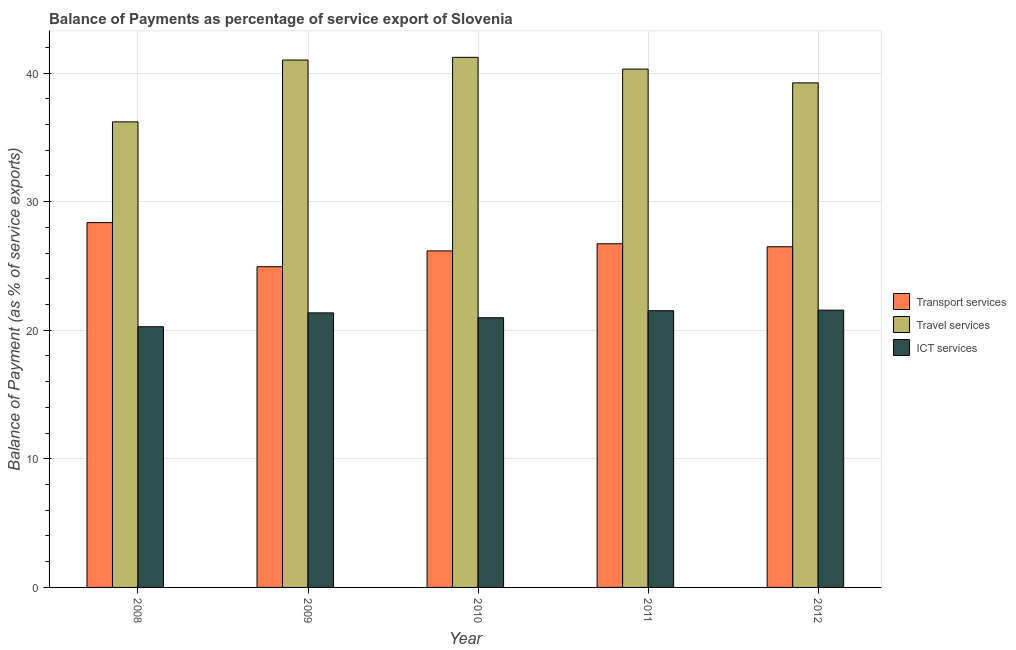How many different coloured bars are there?
Ensure brevity in your answer.  3. How many groups of bars are there?
Your answer should be compact. 5. Are the number of bars on each tick of the X-axis equal?
Provide a short and direct response. Yes. How many bars are there on the 5th tick from the left?
Your answer should be compact. 3. How many bars are there on the 3rd tick from the right?
Provide a succinct answer. 3. What is the label of the 1st group of bars from the left?
Ensure brevity in your answer.  2008. What is the balance of payment of travel services in 2009?
Provide a succinct answer. 41.01. Across all years, what is the maximum balance of payment of transport services?
Offer a terse response. 28.37. Across all years, what is the minimum balance of payment of ict services?
Provide a succinct answer. 20.27. What is the total balance of payment of travel services in the graph?
Provide a short and direct response. 197.99. What is the difference between the balance of payment of ict services in 2009 and that in 2012?
Give a very brief answer. -0.21. What is the difference between the balance of payment of travel services in 2010 and the balance of payment of transport services in 2012?
Provide a short and direct response. 1.99. What is the average balance of payment of ict services per year?
Make the answer very short. 21.14. In the year 2010, what is the difference between the balance of payment of ict services and balance of payment of transport services?
Your answer should be very brief. 0. What is the ratio of the balance of payment of transport services in 2008 to that in 2010?
Your answer should be very brief. 1.08. Is the difference between the balance of payment of travel services in 2009 and 2011 greater than the difference between the balance of payment of ict services in 2009 and 2011?
Make the answer very short. No. What is the difference between the highest and the second highest balance of payment of ict services?
Offer a terse response. 0.04. What is the difference between the highest and the lowest balance of payment of travel services?
Provide a short and direct response. 5.02. In how many years, is the balance of payment of travel services greater than the average balance of payment of travel services taken over all years?
Provide a succinct answer. 3. What does the 3rd bar from the left in 2010 represents?
Ensure brevity in your answer.  ICT services. What does the 2nd bar from the right in 2008 represents?
Provide a succinct answer. Travel services. Is it the case that in every year, the sum of the balance of payment of transport services and balance of payment of travel services is greater than the balance of payment of ict services?
Ensure brevity in your answer.  Yes. How many bars are there?
Keep it short and to the point. 15. Are all the bars in the graph horizontal?
Offer a very short reply. No. How many years are there in the graph?
Make the answer very short. 5. What is the difference between two consecutive major ticks on the Y-axis?
Provide a succinct answer. 10. Are the values on the major ticks of Y-axis written in scientific E-notation?
Offer a very short reply. No. Does the graph contain grids?
Offer a terse response. Yes. How many legend labels are there?
Your response must be concise. 3. What is the title of the graph?
Keep it short and to the point. Balance of Payments as percentage of service export of Slovenia. Does "Infant(male)" appear as one of the legend labels in the graph?
Offer a very short reply. No. What is the label or title of the Y-axis?
Ensure brevity in your answer.  Balance of Payment (as % of service exports). What is the Balance of Payment (as % of service exports) in Transport services in 2008?
Offer a terse response. 28.37. What is the Balance of Payment (as % of service exports) of Travel services in 2008?
Provide a short and direct response. 36.2. What is the Balance of Payment (as % of service exports) in ICT services in 2008?
Keep it short and to the point. 20.27. What is the Balance of Payment (as % of service exports) of Transport services in 2009?
Your response must be concise. 24.94. What is the Balance of Payment (as % of service exports) in Travel services in 2009?
Provide a succinct answer. 41.01. What is the Balance of Payment (as % of service exports) of ICT services in 2009?
Provide a short and direct response. 21.35. What is the Balance of Payment (as % of service exports) of Transport services in 2010?
Your answer should be very brief. 26.17. What is the Balance of Payment (as % of service exports) in Travel services in 2010?
Give a very brief answer. 41.22. What is the Balance of Payment (as % of service exports) of ICT services in 2010?
Provide a short and direct response. 20.97. What is the Balance of Payment (as % of service exports) in Transport services in 2011?
Your answer should be compact. 26.73. What is the Balance of Payment (as % of service exports) in Travel services in 2011?
Your answer should be very brief. 40.31. What is the Balance of Payment (as % of service exports) of ICT services in 2011?
Provide a short and direct response. 21.52. What is the Balance of Payment (as % of service exports) in Transport services in 2012?
Offer a very short reply. 26.49. What is the Balance of Payment (as % of service exports) of Travel services in 2012?
Offer a terse response. 39.24. What is the Balance of Payment (as % of service exports) in ICT services in 2012?
Give a very brief answer. 21.56. Across all years, what is the maximum Balance of Payment (as % of service exports) of Transport services?
Give a very brief answer. 28.37. Across all years, what is the maximum Balance of Payment (as % of service exports) in Travel services?
Keep it short and to the point. 41.22. Across all years, what is the maximum Balance of Payment (as % of service exports) in ICT services?
Offer a very short reply. 21.56. Across all years, what is the minimum Balance of Payment (as % of service exports) of Transport services?
Give a very brief answer. 24.94. Across all years, what is the minimum Balance of Payment (as % of service exports) in Travel services?
Offer a terse response. 36.2. Across all years, what is the minimum Balance of Payment (as % of service exports) of ICT services?
Your response must be concise. 20.27. What is the total Balance of Payment (as % of service exports) in Transport services in the graph?
Provide a succinct answer. 132.7. What is the total Balance of Payment (as % of service exports) of Travel services in the graph?
Offer a terse response. 197.99. What is the total Balance of Payment (as % of service exports) of ICT services in the graph?
Your answer should be very brief. 105.68. What is the difference between the Balance of Payment (as % of service exports) in Transport services in 2008 and that in 2009?
Provide a succinct answer. 3.43. What is the difference between the Balance of Payment (as % of service exports) in Travel services in 2008 and that in 2009?
Your answer should be compact. -4.81. What is the difference between the Balance of Payment (as % of service exports) of ICT services in 2008 and that in 2009?
Ensure brevity in your answer.  -1.08. What is the difference between the Balance of Payment (as % of service exports) of Transport services in 2008 and that in 2010?
Give a very brief answer. 2.2. What is the difference between the Balance of Payment (as % of service exports) in Travel services in 2008 and that in 2010?
Provide a succinct answer. -5.02. What is the difference between the Balance of Payment (as % of service exports) in ICT services in 2008 and that in 2010?
Your answer should be very brief. -0.7. What is the difference between the Balance of Payment (as % of service exports) in Transport services in 2008 and that in 2011?
Provide a short and direct response. 1.65. What is the difference between the Balance of Payment (as % of service exports) in Travel services in 2008 and that in 2011?
Offer a very short reply. -4.1. What is the difference between the Balance of Payment (as % of service exports) in ICT services in 2008 and that in 2011?
Your answer should be compact. -1.25. What is the difference between the Balance of Payment (as % of service exports) in Transport services in 2008 and that in 2012?
Offer a terse response. 1.88. What is the difference between the Balance of Payment (as % of service exports) in Travel services in 2008 and that in 2012?
Provide a succinct answer. -3.03. What is the difference between the Balance of Payment (as % of service exports) in ICT services in 2008 and that in 2012?
Provide a short and direct response. -1.29. What is the difference between the Balance of Payment (as % of service exports) in Transport services in 2009 and that in 2010?
Offer a terse response. -1.23. What is the difference between the Balance of Payment (as % of service exports) of Travel services in 2009 and that in 2010?
Offer a very short reply. -0.21. What is the difference between the Balance of Payment (as % of service exports) in ICT services in 2009 and that in 2010?
Ensure brevity in your answer.  0.38. What is the difference between the Balance of Payment (as % of service exports) of Transport services in 2009 and that in 2011?
Offer a terse response. -1.79. What is the difference between the Balance of Payment (as % of service exports) in Travel services in 2009 and that in 2011?
Keep it short and to the point. 0.7. What is the difference between the Balance of Payment (as % of service exports) of ICT services in 2009 and that in 2011?
Provide a succinct answer. -0.17. What is the difference between the Balance of Payment (as % of service exports) in Transport services in 2009 and that in 2012?
Provide a short and direct response. -1.55. What is the difference between the Balance of Payment (as % of service exports) in Travel services in 2009 and that in 2012?
Offer a very short reply. 1.77. What is the difference between the Balance of Payment (as % of service exports) in ICT services in 2009 and that in 2012?
Your answer should be compact. -0.21. What is the difference between the Balance of Payment (as % of service exports) of Transport services in 2010 and that in 2011?
Ensure brevity in your answer.  -0.55. What is the difference between the Balance of Payment (as % of service exports) in Travel services in 2010 and that in 2011?
Your response must be concise. 0.92. What is the difference between the Balance of Payment (as % of service exports) of ICT services in 2010 and that in 2011?
Keep it short and to the point. -0.55. What is the difference between the Balance of Payment (as % of service exports) of Transport services in 2010 and that in 2012?
Your answer should be very brief. -0.32. What is the difference between the Balance of Payment (as % of service exports) in Travel services in 2010 and that in 2012?
Make the answer very short. 1.99. What is the difference between the Balance of Payment (as % of service exports) in ICT services in 2010 and that in 2012?
Offer a terse response. -0.59. What is the difference between the Balance of Payment (as % of service exports) of Transport services in 2011 and that in 2012?
Offer a terse response. 0.23. What is the difference between the Balance of Payment (as % of service exports) of Travel services in 2011 and that in 2012?
Ensure brevity in your answer.  1.07. What is the difference between the Balance of Payment (as % of service exports) in ICT services in 2011 and that in 2012?
Give a very brief answer. -0.04. What is the difference between the Balance of Payment (as % of service exports) in Transport services in 2008 and the Balance of Payment (as % of service exports) in Travel services in 2009?
Your response must be concise. -12.64. What is the difference between the Balance of Payment (as % of service exports) of Transport services in 2008 and the Balance of Payment (as % of service exports) of ICT services in 2009?
Provide a succinct answer. 7.02. What is the difference between the Balance of Payment (as % of service exports) in Travel services in 2008 and the Balance of Payment (as % of service exports) in ICT services in 2009?
Provide a succinct answer. 14.85. What is the difference between the Balance of Payment (as % of service exports) of Transport services in 2008 and the Balance of Payment (as % of service exports) of Travel services in 2010?
Provide a succinct answer. -12.85. What is the difference between the Balance of Payment (as % of service exports) in Transport services in 2008 and the Balance of Payment (as % of service exports) in ICT services in 2010?
Ensure brevity in your answer.  7.4. What is the difference between the Balance of Payment (as % of service exports) of Travel services in 2008 and the Balance of Payment (as % of service exports) of ICT services in 2010?
Provide a short and direct response. 15.23. What is the difference between the Balance of Payment (as % of service exports) of Transport services in 2008 and the Balance of Payment (as % of service exports) of Travel services in 2011?
Offer a terse response. -11.94. What is the difference between the Balance of Payment (as % of service exports) in Transport services in 2008 and the Balance of Payment (as % of service exports) in ICT services in 2011?
Make the answer very short. 6.85. What is the difference between the Balance of Payment (as % of service exports) in Travel services in 2008 and the Balance of Payment (as % of service exports) in ICT services in 2011?
Your response must be concise. 14.69. What is the difference between the Balance of Payment (as % of service exports) of Transport services in 2008 and the Balance of Payment (as % of service exports) of Travel services in 2012?
Make the answer very short. -10.87. What is the difference between the Balance of Payment (as % of service exports) in Transport services in 2008 and the Balance of Payment (as % of service exports) in ICT services in 2012?
Your response must be concise. 6.81. What is the difference between the Balance of Payment (as % of service exports) in Travel services in 2008 and the Balance of Payment (as % of service exports) in ICT services in 2012?
Keep it short and to the point. 14.64. What is the difference between the Balance of Payment (as % of service exports) in Transport services in 2009 and the Balance of Payment (as % of service exports) in Travel services in 2010?
Your response must be concise. -16.28. What is the difference between the Balance of Payment (as % of service exports) in Transport services in 2009 and the Balance of Payment (as % of service exports) in ICT services in 2010?
Give a very brief answer. 3.97. What is the difference between the Balance of Payment (as % of service exports) of Travel services in 2009 and the Balance of Payment (as % of service exports) of ICT services in 2010?
Give a very brief answer. 20.04. What is the difference between the Balance of Payment (as % of service exports) in Transport services in 2009 and the Balance of Payment (as % of service exports) in Travel services in 2011?
Offer a terse response. -15.37. What is the difference between the Balance of Payment (as % of service exports) of Transport services in 2009 and the Balance of Payment (as % of service exports) of ICT services in 2011?
Your answer should be very brief. 3.42. What is the difference between the Balance of Payment (as % of service exports) of Travel services in 2009 and the Balance of Payment (as % of service exports) of ICT services in 2011?
Give a very brief answer. 19.49. What is the difference between the Balance of Payment (as % of service exports) of Transport services in 2009 and the Balance of Payment (as % of service exports) of Travel services in 2012?
Ensure brevity in your answer.  -14.3. What is the difference between the Balance of Payment (as % of service exports) of Transport services in 2009 and the Balance of Payment (as % of service exports) of ICT services in 2012?
Your answer should be very brief. 3.38. What is the difference between the Balance of Payment (as % of service exports) of Travel services in 2009 and the Balance of Payment (as % of service exports) of ICT services in 2012?
Your answer should be very brief. 19.45. What is the difference between the Balance of Payment (as % of service exports) of Transport services in 2010 and the Balance of Payment (as % of service exports) of Travel services in 2011?
Your answer should be very brief. -14.14. What is the difference between the Balance of Payment (as % of service exports) in Transport services in 2010 and the Balance of Payment (as % of service exports) in ICT services in 2011?
Ensure brevity in your answer.  4.65. What is the difference between the Balance of Payment (as % of service exports) in Travel services in 2010 and the Balance of Payment (as % of service exports) in ICT services in 2011?
Provide a succinct answer. 19.71. What is the difference between the Balance of Payment (as % of service exports) in Transport services in 2010 and the Balance of Payment (as % of service exports) in Travel services in 2012?
Provide a succinct answer. -13.07. What is the difference between the Balance of Payment (as % of service exports) in Transport services in 2010 and the Balance of Payment (as % of service exports) in ICT services in 2012?
Your response must be concise. 4.61. What is the difference between the Balance of Payment (as % of service exports) in Travel services in 2010 and the Balance of Payment (as % of service exports) in ICT services in 2012?
Provide a short and direct response. 19.66. What is the difference between the Balance of Payment (as % of service exports) in Transport services in 2011 and the Balance of Payment (as % of service exports) in Travel services in 2012?
Keep it short and to the point. -12.51. What is the difference between the Balance of Payment (as % of service exports) of Transport services in 2011 and the Balance of Payment (as % of service exports) of ICT services in 2012?
Offer a very short reply. 5.16. What is the difference between the Balance of Payment (as % of service exports) in Travel services in 2011 and the Balance of Payment (as % of service exports) in ICT services in 2012?
Your response must be concise. 18.75. What is the average Balance of Payment (as % of service exports) of Transport services per year?
Ensure brevity in your answer.  26.54. What is the average Balance of Payment (as % of service exports) of Travel services per year?
Offer a terse response. 39.6. What is the average Balance of Payment (as % of service exports) in ICT services per year?
Your answer should be very brief. 21.14. In the year 2008, what is the difference between the Balance of Payment (as % of service exports) of Transport services and Balance of Payment (as % of service exports) of Travel services?
Offer a terse response. -7.83. In the year 2008, what is the difference between the Balance of Payment (as % of service exports) in Transport services and Balance of Payment (as % of service exports) in ICT services?
Your answer should be very brief. 8.1. In the year 2008, what is the difference between the Balance of Payment (as % of service exports) of Travel services and Balance of Payment (as % of service exports) of ICT services?
Keep it short and to the point. 15.93. In the year 2009, what is the difference between the Balance of Payment (as % of service exports) in Transport services and Balance of Payment (as % of service exports) in Travel services?
Give a very brief answer. -16.07. In the year 2009, what is the difference between the Balance of Payment (as % of service exports) of Transport services and Balance of Payment (as % of service exports) of ICT services?
Provide a short and direct response. 3.59. In the year 2009, what is the difference between the Balance of Payment (as % of service exports) of Travel services and Balance of Payment (as % of service exports) of ICT services?
Your answer should be very brief. 19.66. In the year 2010, what is the difference between the Balance of Payment (as % of service exports) of Transport services and Balance of Payment (as % of service exports) of Travel services?
Your answer should be very brief. -15.05. In the year 2010, what is the difference between the Balance of Payment (as % of service exports) in Transport services and Balance of Payment (as % of service exports) in ICT services?
Ensure brevity in your answer.  5.2. In the year 2010, what is the difference between the Balance of Payment (as % of service exports) in Travel services and Balance of Payment (as % of service exports) in ICT services?
Provide a succinct answer. 20.25. In the year 2011, what is the difference between the Balance of Payment (as % of service exports) in Transport services and Balance of Payment (as % of service exports) in Travel services?
Make the answer very short. -13.58. In the year 2011, what is the difference between the Balance of Payment (as % of service exports) of Transport services and Balance of Payment (as % of service exports) of ICT services?
Offer a terse response. 5.21. In the year 2011, what is the difference between the Balance of Payment (as % of service exports) of Travel services and Balance of Payment (as % of service exports) of ICT services?
Give a very brief answer. 18.79. In the year 2012, what is the difference between the Balance of Payment (as % of service exports) in Transport services and Balance of Payment (as % of service exports) in Travel services?
Offer a very short reply. -12.75. In the year 2012, what is the difference between the Balance of Payment (as % of service exports) of Transport services and Balance of Payment (as % of service exports) of ICT services?
Give a very brief answer. 4.93. In the year 2012, what is the difference between the Balance of Payment (as % of service exports) of Travel services and Balance of Payment (as % of service exports) of ICT services?
Provide a short and direct response. 17.67. What is the ratio of the Balance of Payment (as % of service exports) of Transport services in 2008 to that in 2009?
Your answer should be very brief. 1.14. What is the ratio of the Balance of Payment (as % of service exports) in Travel services in 2008 to that in 2009?
Your answer should be very brief. 0.88. What is the ratio of the Balance of Payment (as % of service exports) in ICT services in 2008 to that in 2009?
Provide a short and direct response. 0.95. What is the ratio of the Balance of Payment (as % of service exports) in Transport services in 2008 to that in 2010?
Give a very brief answer. 1.08. What is the ratio of the Balance of Payment (as % of service exports) of Travel services in 2008 to that in 2010?
Ensure brevity in your answer.  0.88. What is the ratio of the Balance of Payment (as % of service exports) of ICT services in 2008 to that in 2010?
Offer a very short reply. 0.97. What is the ratio of the Balance of Payment (as % of service exports) in Transport services in 2008 to that in 2011?
Give a very brief answer. 1.06. What is the ratio of the Balance of Payment (as % of service exports) of Travel services in 2008 to that in 2011?
Keep it short and to the point. 0.9. What is the ratio of the Balance of Payment (as % of service exports) of ICT services in 2008 to that in 2011?
Make the answer very short. 0.94. What is the ratio of the Balance of Payment (as % of service exports) in Transport services in 2008 to that in 2012?
Provide a short and direct response. 1.07. What is the ratio of the Balance of Payment (as % of service exports) of Travel services in 2008 to that in 2012?
Give a very brief answer. 0.92. What is the ratio of the Balance of Payment (as % of service exports) of ICT services in 2008 to that in 2012?
Provide a succinct answer. 0.94. What is the ratio of the Balance of Payment (as % of service exports) in Transport services in 2009 to that in 2010?
Ensure brevity in your answer.  0.95. What is the ratio of the Balance of Payment (as % of service exports) in ICT services in 2009 to that in 2010?
Give a very brief answer. 1.02. What is the ratio of the Balance of Payment (as % of service exports) in Transport services in 2009 to that in 2011?
Your response must be concise. 0.93. What is the ratio of the Balance of Payment (as % of service exports) in Travel services in 2009 to that in 2011?
Make the answer very short. 1.02. What is the ratio of the Balance of Payment (as % of service exports) of ICT services in 2009 to that in 2011?
Your answer should be very brief. 0.99. What is the ratio of the Balance of Payment (as % of service exports) of Transport services in 2009 to that in 2012?
Offer a terse response. 0.94. What is the ratio of the Balance of Payment (as % of service exports) of Travel services in 2009 to that in 2012?
Give a very brief answer. 1.05. What is the ratio of the Balance of Payment (as % of service exports) of ICT services in 2009 to that in 2012?
Ensure brevity in your answer.  0.99. What is the ratio of the Balance of Payment (as % of service exports) of Transport services in 2010 to that in 2011?
Provide a short and direct response. 0.98. What is the ratio of the Balance of Payment (as % of service exports) in Travel services in 2010 to that in 2011?
Ensure brevity in your answer.  1.02. What is the ratio of the Balance of Payment (as % of service exports) of ICT services in 2010 to that in 2011?
Your answer should be compact. 0.97. What is the ratio of the Balance of Payment (as % of service exports) in Transport services in 2010 to that in 2012?
Your answer should be very brief. 0.99. What is the ratio of the Balance of Payment (as % of service exports) in Travel services in 2010 to that in 2012?
Ensure brevity in your answer.  1.05. What is the ratio of the Balance of Payment (as % of service exports) in ICT services in 2010 to that in 2012?
Offer a terse response. 0.97. What is the ratio of the Balance of Payment (as % of service exports) in Transport services in 2011 to that in 2012?
Your answer should be very brief. 1.01. What is the ratio of the Balance of Payment (as % of service exports) in Travel services in 2011 to that in 2012?
Offer a very short reply. 1.03. What is the difference between the highest and the second highest Balance of Payment (as % of service exports) in Transport services?
Make the answer very short. 1.65. What is the difference between the highest and the second highest Balance of Payment (as % of service exports) of Travel services?
Ensure brevity in your answer.  0.21. What is the difference between the highest and the second highest Balance of Payment (as % of service exports) of ICT services?
Make the answer very short. 0.04. What is the difference between the highest and the lowest Balance of Payment (as % of service exports) of Transport services?
Make the answer very short. 3.43. What is the difference between the highest and the lowest Balance of Payment (as % of service exports) of Travel services?
Give a very brief answer. 5.02. What is the difference between the highest and the lowest Balance of Payment (as % of service exports) in ICT services?
Offer a terse response. 1.29. 